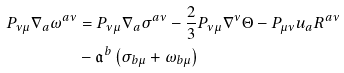<formula> <loc_0><loc_0><loc_500><loc_500>P _ { \nu \mu } \nabla _ { a } \omega ^ { a \nu } & = P _ { \nu \mu } \nabla _ { a } \sigma ^ { a \nu } - \frac { 2 } { 3 } P _ { \nu \mu } \nabla ^ { \nu } \Theta - P _ { \mu \nu } u _ { a } R ^ { a \nu } \\ & - { \mathfrak a } ^ { b } \left ( \sigma _ { b \mu } + \omega _ { b \mu } \right )</formula> 